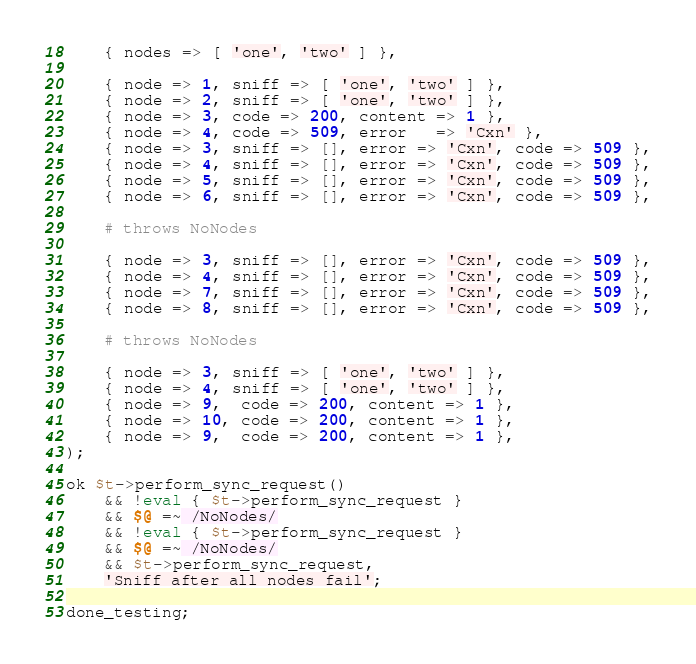Convert code to text. <code><loc_0><loc_0><loc_500><loc_500><_Perl_>    { nodes => [ 'one', 'two' ] },

    { node => 1, sniff => [ 'one', 'two' ] },
    { node => 2, sniff => [ 'one', 'two' ] },
    { node => 3, code => 200, content => 1 },
    { node => 4, code => 509, error   => 'Cxn' },
    { node => 3, sniff => [], error => 'Cxn', code => 509 },
    { node => 4, sniff => [], error => 'Cxn', code => 509 },
    { node => 5, sniff => [], error => 'Cxn', code => 509 },
    { node => 6, sniff => [], error => 'Cxn', code => 509 },

    # throws NoNodes

    { node => 3, sniff => [], error => 'Cxn', code => 509 },
    { node => 4, sniff => [], error => 'Cxn', code => 509 },
    { node => 7, sniff => [], error => 'Cxn', code => 509 },
    { node => 8, sniff => [], error => 'Cxn', code => 509 },

    # throws NoNodes

    { node => 3, sniff => [ 'one', 'two' ] },
    { node => 4, sniff => [ 'one', 'two' ] },
    { node => 9,  code => 200, content => 1 },
    { node => 10, code => 200, content => 1 },
    { node => 9,  code => 200, content => 1 },
);

ok $t->perform_sync_request()
    && !eval { $t->perform_sync_request }
    && $@ =~ /NoNodes/
    && !eval { $t->perform_sync_request }
    && $@ =~ /NoNodes/
    && $t->perform_sync_request,
    'Sniff after all nodes fail';

done_testing;
</code> 